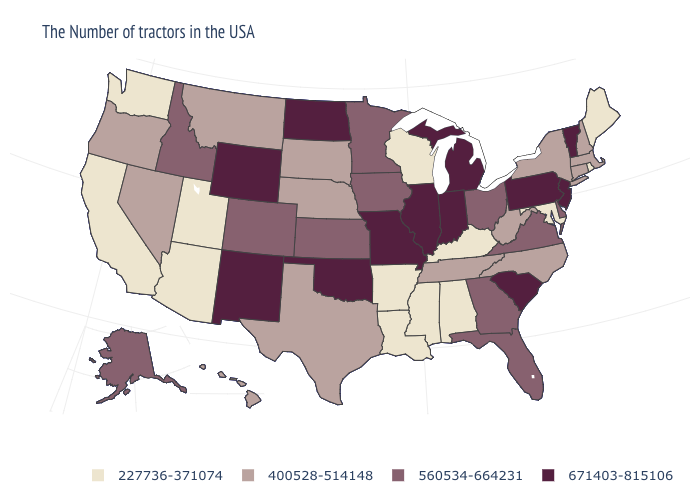Name the states that have a value in the range 227736-371074?
Concise answer only. Maine, Rhode Island, Maryland, Kentucky, Alabama, Wisconsin, Mississippi, Louisiana, Arkansas, Utah, Arizona, California, Washington. Is the legend a continuous bar?
Be succinct. No. Name the states that have a value in the range 560534-664231?
Answer briefly. Delaware, Virginia, Ohio, Florida, Georgia, Minnesota, Iowa, Kansas, Colorado, Idaho, Alaska. Name the states that have a value in the range 671403-815106?
Write a very short answer. Vermont, New Jersey, Pennsylvania, South Carolina, Michigan, Indiana, Illinois, Missouri, Oklahoma, North Dakota, Wyoming, New Mexico. Which states have the lowest value in the USA?
Give a very brief answer. Maine, Rhode Island, Maryland, Kentucky, Alabama, Wisconsin, Mississippi, Louisiana, Arkansas, Utah, Arizona, California, Washington. Among the states that border New Hampshire , does Maine have the lowest value?
Keep it brief. Yes. What is the value of Mississippi?
Concise answer only. 227736-371074. Among the states that border North Carolina , which have the highest value?
Keep it brief. South Carolina. Name the states that have a value in the range 560534-664231?
Write a very short answer. Delaware, Virginia, Ohio, Florida, Georgia, Minnesota, Iowa, Kansas, Colorado, Idaho, Alaska. Name the states that have a value in the range 671403-815106?
Keep it brief. Vermont, New Jersey, Pennsylvania, South Carolina, Michigan, Indiana, Illinois, Missouri, Oklahoma, North Dakota, Wyoming, New Mexico. What is the value of Michigan?
Keep it brief. 671403-815106. What is the value of Wisconsin?
Answer briefly. 227736-371074. How many symbols are there in the legend?
Be succinct. 4. 